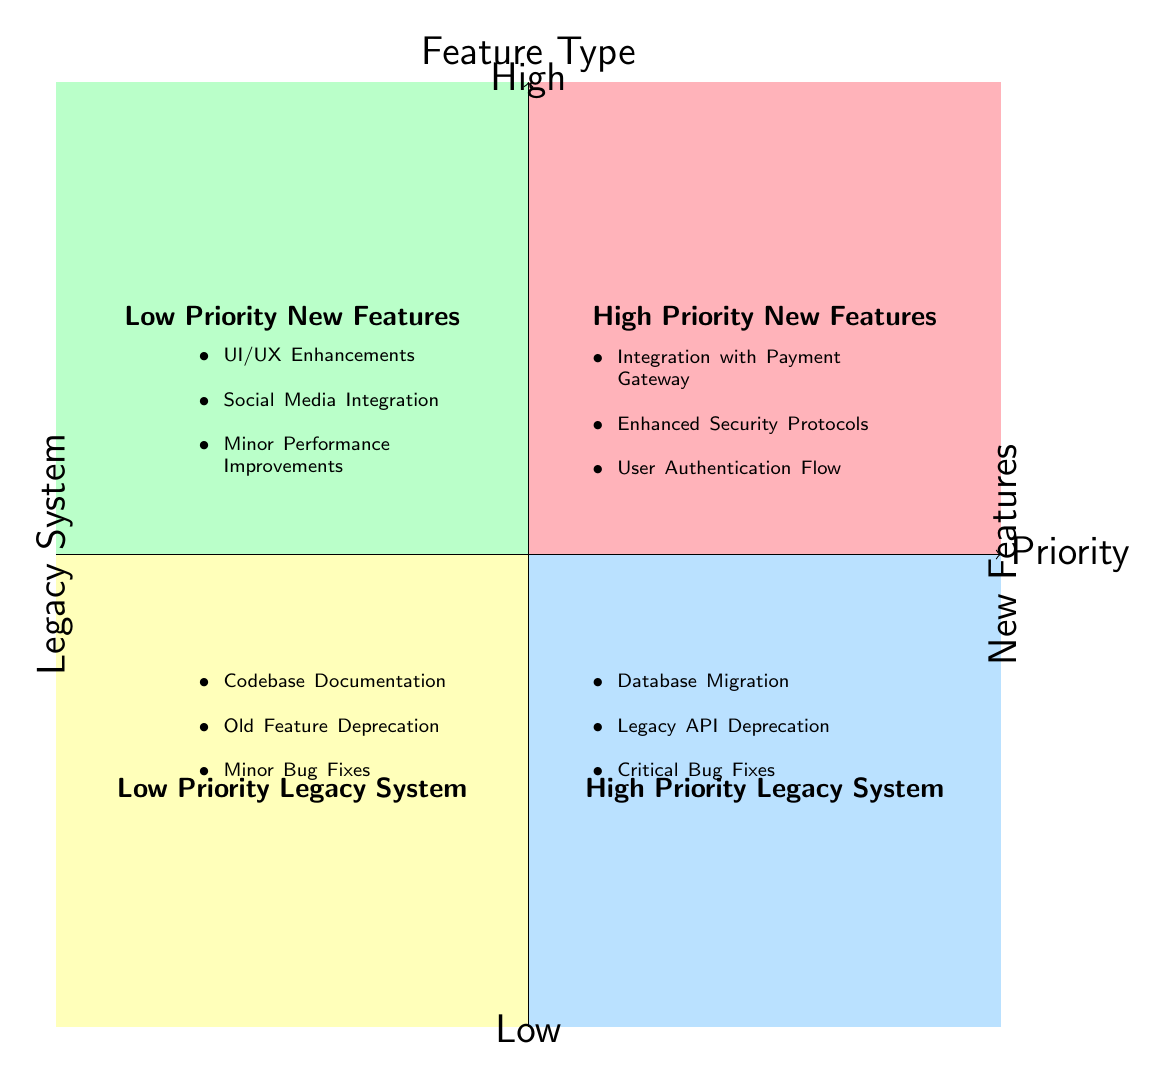What are the elements in the "High Priority New Features" quadrant? The quadrant labeled "High Priority New Features" contains three elements listed underneath it: Integration with Payment Gateway, Enhanced Security Protocols, and User Authentication Flow.
Answer: Integration with Payment Gateway, Enhanced Security Protocols, User Authentication Flow How many elements are listed under "Low Priority Legacy System"? This quadrant is designated as "Low Priority Legacy System", and it contains three listed elements, which are: Codebase Documentation, Old Feature Deprecation, and Minor Bug Fixes.
Answer: 3 Which quadrant includes "Database Migration"? The element "Database Migration" is found in the quadrant labeled "High Priority Legacy System". This can be deduced by locating the element and then noting the quadrant it resides in.
Answer: High Priority Legacy System What is the relationship between "Enhanced Security Protocols" and "Codebase Documentation"? "Enhanced Security Protocols" is located in the "High Priority New Features" quadrant, while "Codebase Documentation" is in the "Low Priority Legacy System" quadrant. The connection pertains to their feature types: one is a new feature and the other pertains to a legacy system.
Answer: No direct relationship Which quadrant has the highest priority features? The quadrants that contain the highest priority features are those situated in the upper half of the chart: "High Priority New Features" and "High Priority Legacy System". This is indicative of the priority level of the features being addressed.
Answer: High Priority New Features, High Priority Legacy System 